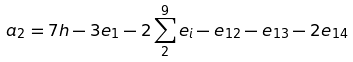Convert formula to latex. <formula><loc_0><loc_0><loc_500><loc_500>a _ { 2 } = 7 h - 3 e _ { 1 } - 2 \sum _ { 2 } ^ { 9 } e _ { i } - e _ { 1 2 } - e _ { 1 3 } - 2 e _ { 1 4 }</formula> 